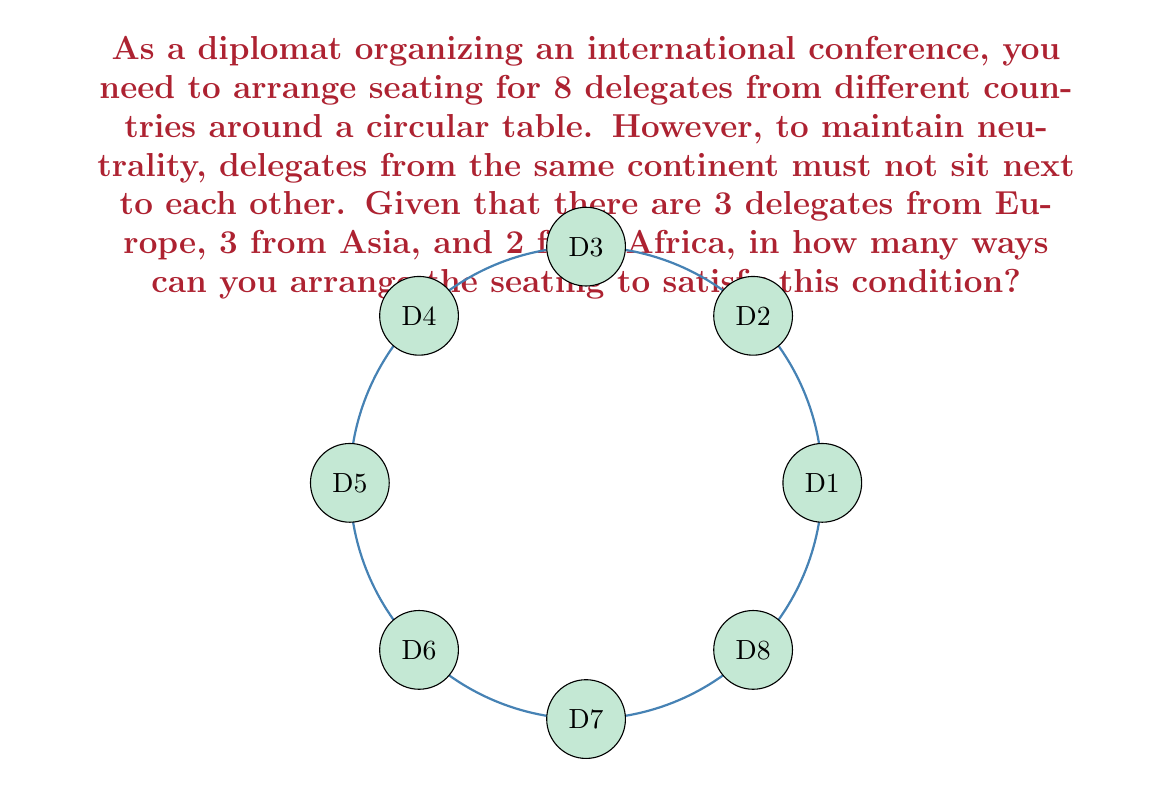Can you answer this question? Let's approach this step-by-step using group theory concepts:

1) First, we need to consider the total number of delegates: 8.

2) In a circular arrangement, rotations are considered the same, so we can fix one delegate's position. Let's fix an European delegate in the first position.

3) Now, we need to arrange the remaining 7 delegates: 2 Europeans, 3 Asians, and 2 Africans.

4) To satisfy the condition that delegates from the same continent must not sit next to each other, we can think of this as arranging the delegates from Asia and Africa first, leaving gaps for the Europeans.

5) So, we first need to choose positions for the 2 remaining Europeans out of the 6 available positions (excluding the positions next to the fixed European). This can be done in $\binom{6}{2} = 15$ ways.

6) Once the European positions are fixed, we need to arrange 3 Asians and 2 Africans in the remaining 5 positions. This is a straightforward permutation: $\frac{5!}{3!2!} = 10$ ways.

7) By the multiplication principle, the total number of arrangements is:

   $$ 15 \times 10 = 150 $$

Therefore, there are 150 possible seating arrangements that satisfy the given condition.
Answer: 150 